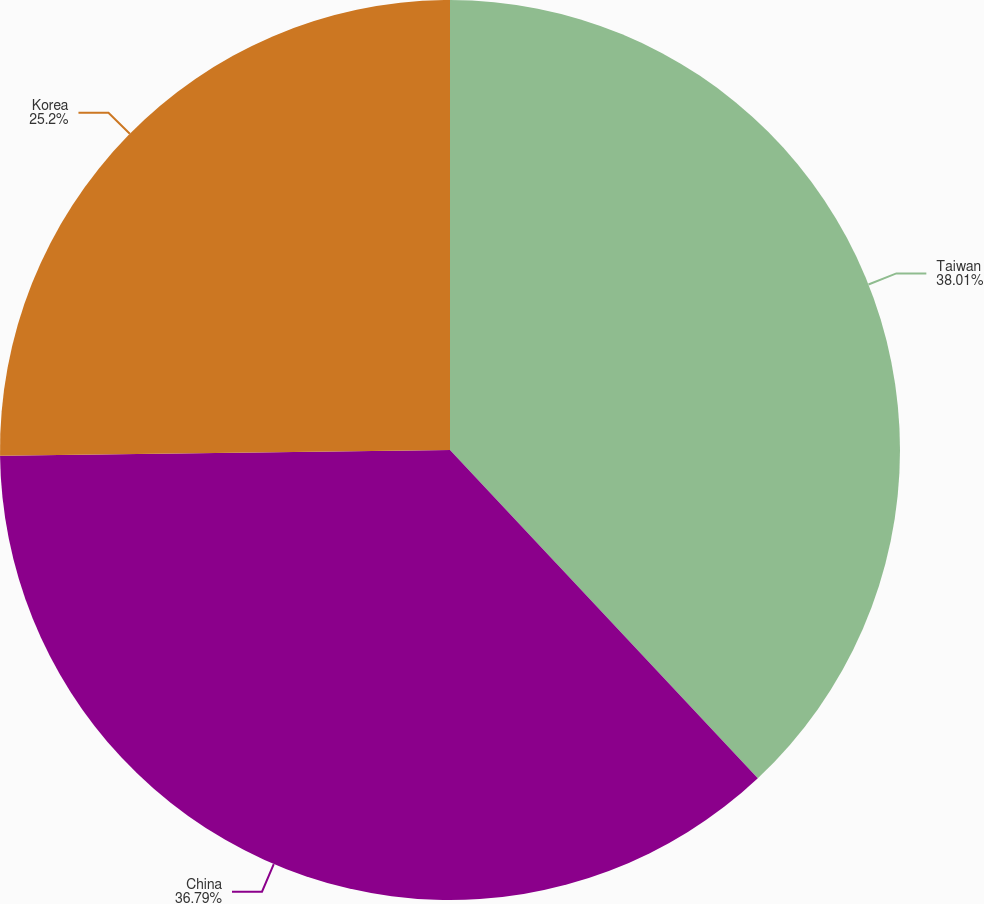<chart> <loc_0><loc_0><loc_500><loc_500><pie_chart><fcel>Taiwan<fcel>China<fcel>Korea<nl><fcel>38.01%<fcel>36.79%<fcel>25.2%<nl></chart> 